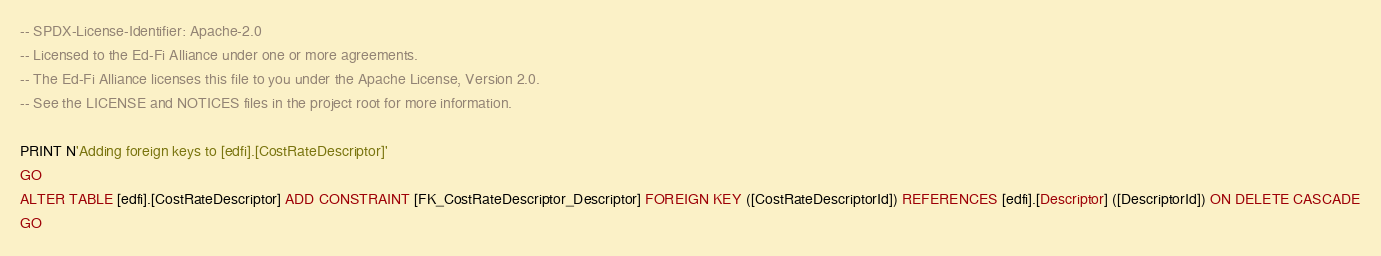Convert code to text. <code><loc_0><loc_0><loc_500><loc_500><_SQL_>-- SPDX-License-Identifier: Apache-2.0
-- Licensed to the Ed-Fi Alliance under one or more agreements.
-- The Ed-Fi Alliance licenses this file to you under the Apache License, Version 2.0.
-- See the LICENSE and NOTICES files in the project root for more information.

PRINT N'Adding foreign keys to [edfi].[CostRateDescriptor]'
GO
ALTER TABLE [edfi].[CostRateDescriptor] ADD CONSTRAINT [FK_CostRateDescriptor_Descriptor] FOREIGN KEY ([CostRateDescriptorId]) REFERENCES [edfi].[Descriptor] ([DescriptorId]) ON DELETE CASCADE
GO
</code> 